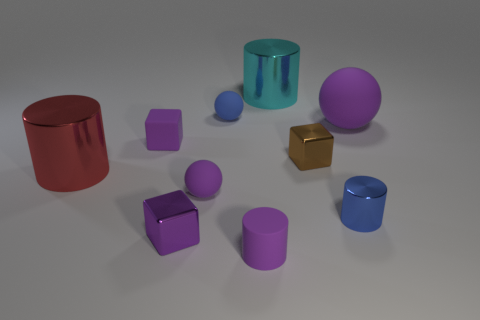Subtract all metallic cylinders. How many cylinders are left? 1 Subtract all brown blocks. How many blocks are left? 2 Subtract all gray spheres. Subtract all cyan cubes. How many spheres are left? 3 Subtract all gray blocks. How many cyan cylinders are left? 1 Subtract all big purple things. Subtract all tiny blue metallic cylinders. How many objects are left? 8 Add 7 small brown metallic cubes. How many small brown metallic cubes are left? 8 Add 5 purple objects. How many purple objects exist? 10 Subtract 1 purple balls. How many objects are left? 9 Subtract all blocks. How many objects are left? 7 Subtract 2 cylinders. How many cylinders are left? 2 